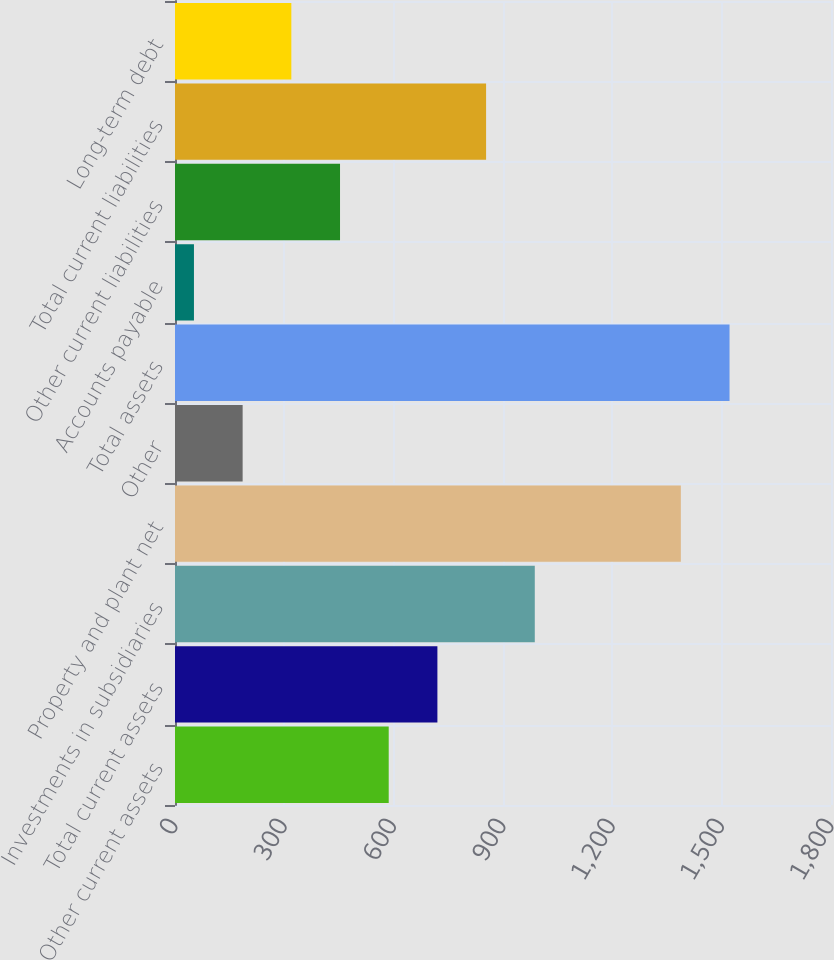Convert chart to OTSL. <chart><loc_0><loc_0><loc_500><loc_500><bar_chart><fcel>Other current assets<fcel>Total current assets<fcel>Investments in subsidiaries<fcel>Property and plant net<fcel>Other<fcel>Total assets<fcel>Accounts payable<fcel>Other current liabilities<fcel>Total current liabilities<fcel>Long-term debt<nl><fcel>586.4<fcel>720<fcel>987.2<fcel>1388<fcel>185.6<fcel>1521.6<fcel>52<fcel>452.8<fcel>853.6<fcel>319.2<nl></chart> 